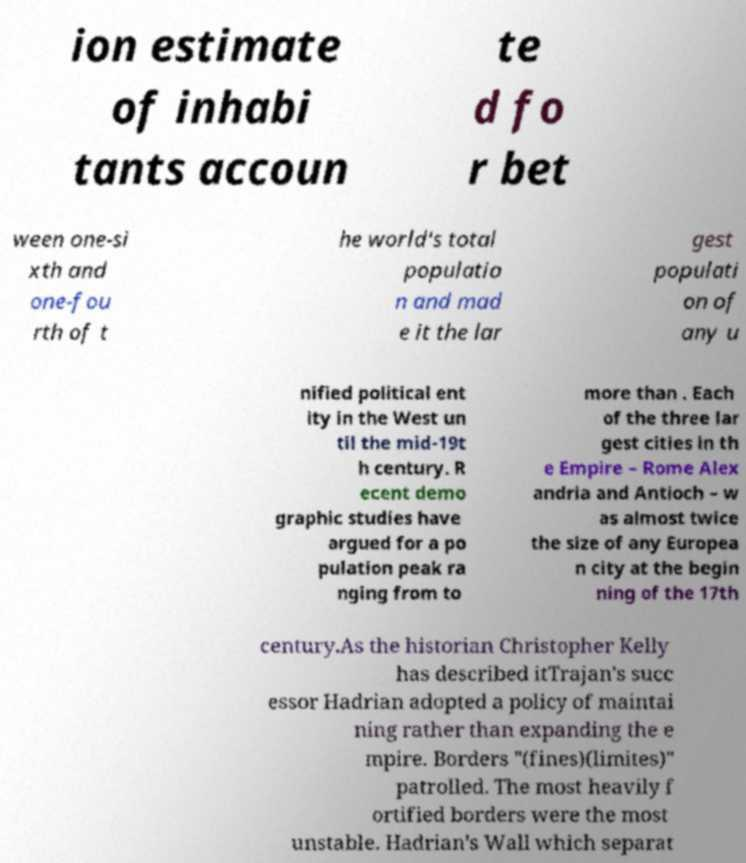Could you assist in decoding the text presented in this image and type it out clearly? ion estimate of inhabi tants accoun te d fo r bet ween one-si xth and one-fou rth of t he world's total populatio n and mad e it the lar gest populati on of any u nified political ent ity in the West un til the mid-19t h century. R ecent demo graphic studies have argued for a po pulation peak ra nging from to more than . Each of the three lar gest cities in th e Empire – Rome Alex andria and Antioch – w as almost twice the size of any Europea n city at the begin ning of the 17th century.As the historian Christopher Kelly has described itTrajan's succ essor Hadrian adopted a policy of maintai ning rather than expanding the e mpire. Borders "(fines)(limites)" patrolled. The most heavily f ortified borders were the most unstable. Hadrian's Wall which separat 